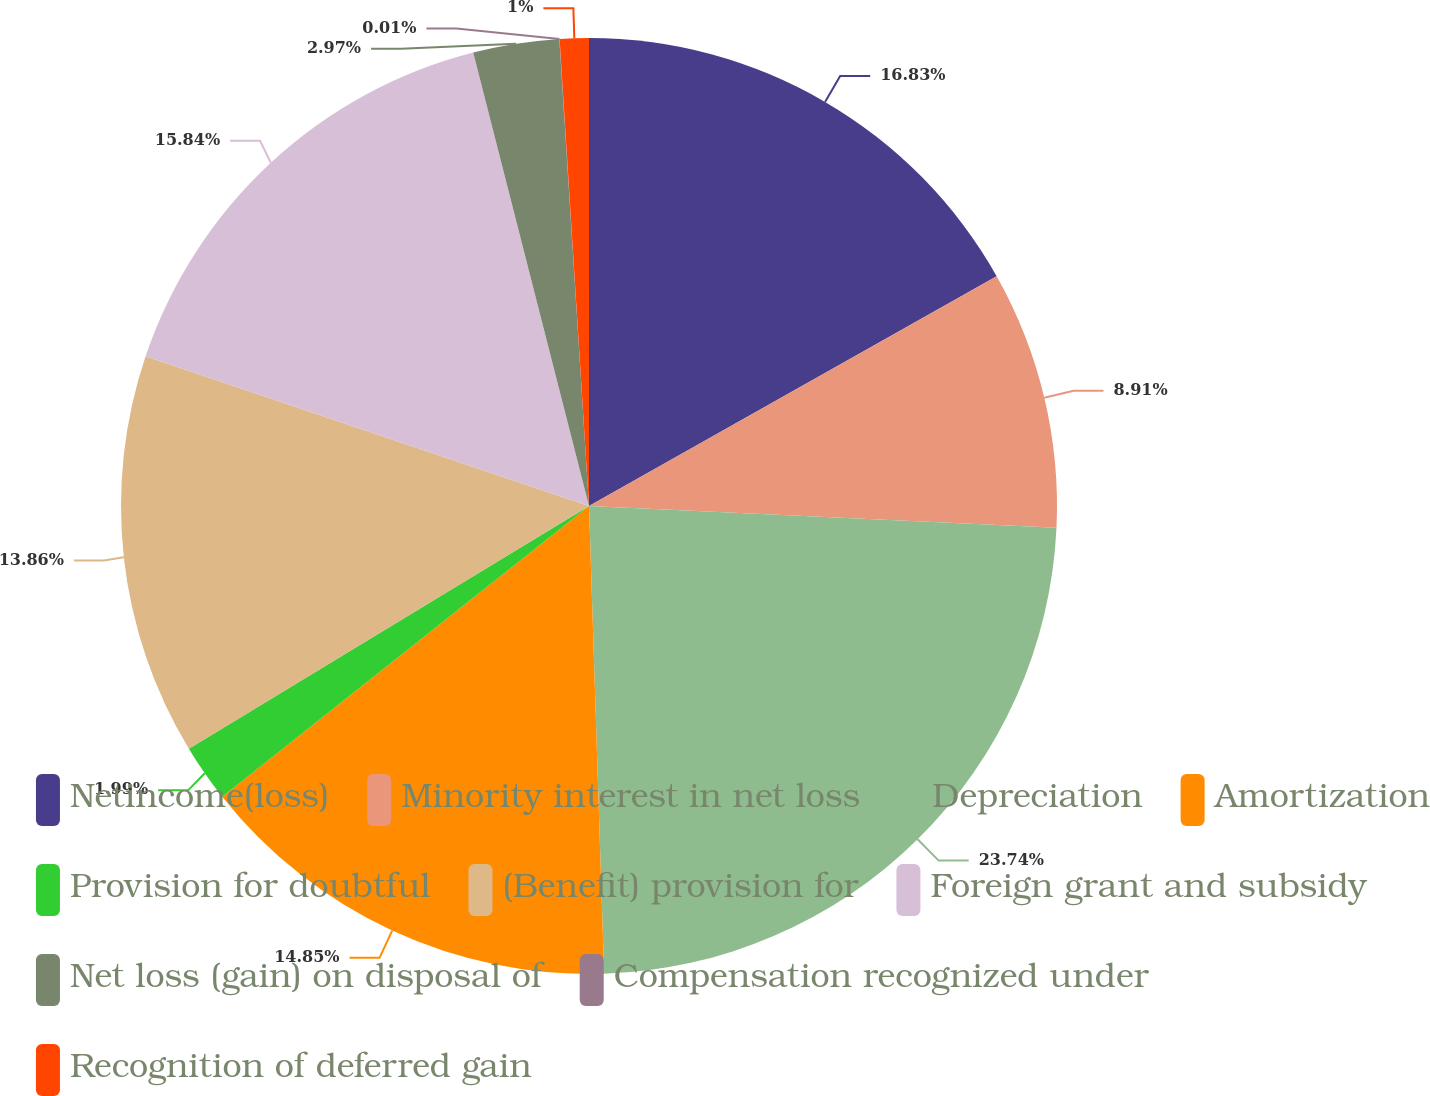Convert chart to OTSL. <chart><loc_0><loc_0><loc_500><loc_500><pie_chart><fcel>Netincome(loss)<fcel>Minority interest in net loss<fcel>Depreciation<fcel>Amortization<fcel>Provision for doubtful<fcel>(Benefit) provision for<fcel>Foreign grant and subsidy<fcel>Net loss (gain) on disposal of<fcel>Compensation recognized under<fcel>Recognition of deferred gain<nl><fcel>16.83%<fcel>8.91%<fcel>23.75%<fcel>14.85%<fcel>1.99%<fcel>13.86%<fcel>15.84%<fcel>2.97%<fcel>0.01%<fcel>1.0%<nl></chart> 